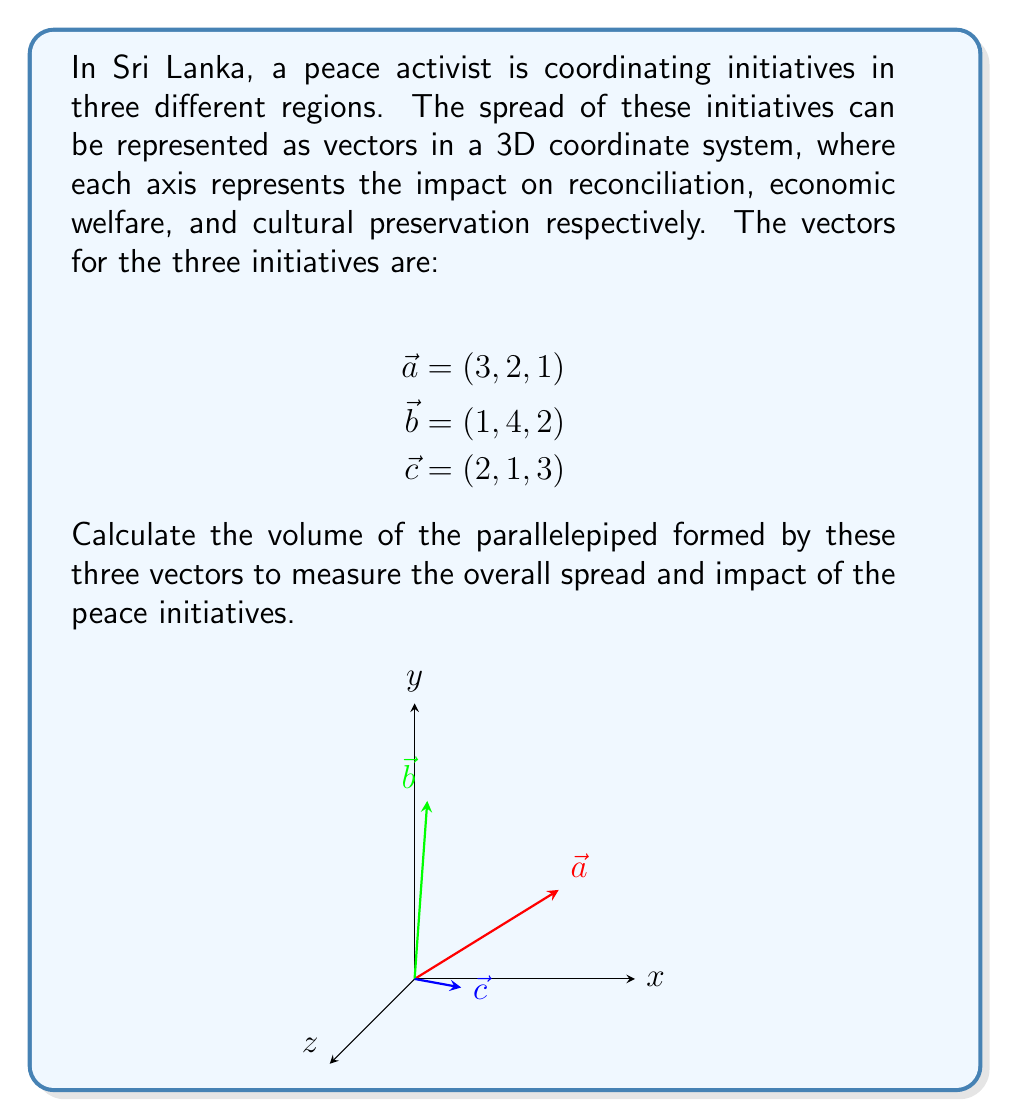Can you solve this math problem? To calculate the volume of the parallelepiped formed by three vectors, we can use the scalar triple product. The formula is:

$$V = |\vec{a} \cdot (\vec{b} \times \vec{c})|$$

Let's solve this step by step:

1) First, we need to calculate $\vec{b} \times \vec{c}$:

   $$\vec{b} \times \vec{c} = \begin{vmatrix} 
   \hat{i} & \hat{j} & \hat{k} \\
   1 & 4 & 2 \\
   2 & 1 & 3
   \end{vmatrix}$$

   $$= (4 \cdot 3 - 2 \cdot 1)\hat{i} - (1 \cdot 3 - 2 \cdot 2)\hat{j} + (1 \cdot 1 - 4 \cdot 2)\hat{k}$$
   
   $$= 10\hat{i} - 1\hat{j} - 7\hat{k}$$

2) Now, we calculate $\vec{a} \cdot (\vec{b} \times \vec{c})$:

   $$\vec{a} \cdot (10, -1, -7) = 3 \cdot 10 + 2 \cdot (-1) + 1 \cdot (-7)$$
   
   $$= 30 - 2 - 7 = 21$$

3) The volume is the absolute value of this result:

   $$V = |21| = 21$$

Therefore, the volume of the parallelepiped, representing the spread and impact of the peace initiatives, is 21 cubic units.
Answer: 21 cubic units 